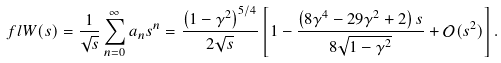Convert formula to latex. <formula><loc_0><loc_0><loc_500><loc_500>\ f l W ( s ) = \frac { 1 } { \sqrt { s } } \sum _ { n = 0 } ^ { \infty } a _ { n } s ^ { n } = \frac { \left ( 1 - \gamma ^ { 2 } \right ) ^ { 5 / 4 } } { 2 \sqrt { s } } \left [ 1 - \frac { \left ( 8 \gamma ^ { 4 } - 2 9 \gamma ^ { 2 } + 2 \right ) s } { 8 \sqrt { 1 - \gamma ^ { 2 } } } + \mathcal { O } ( s ^ { 2 } ) \right ] .</formula> 